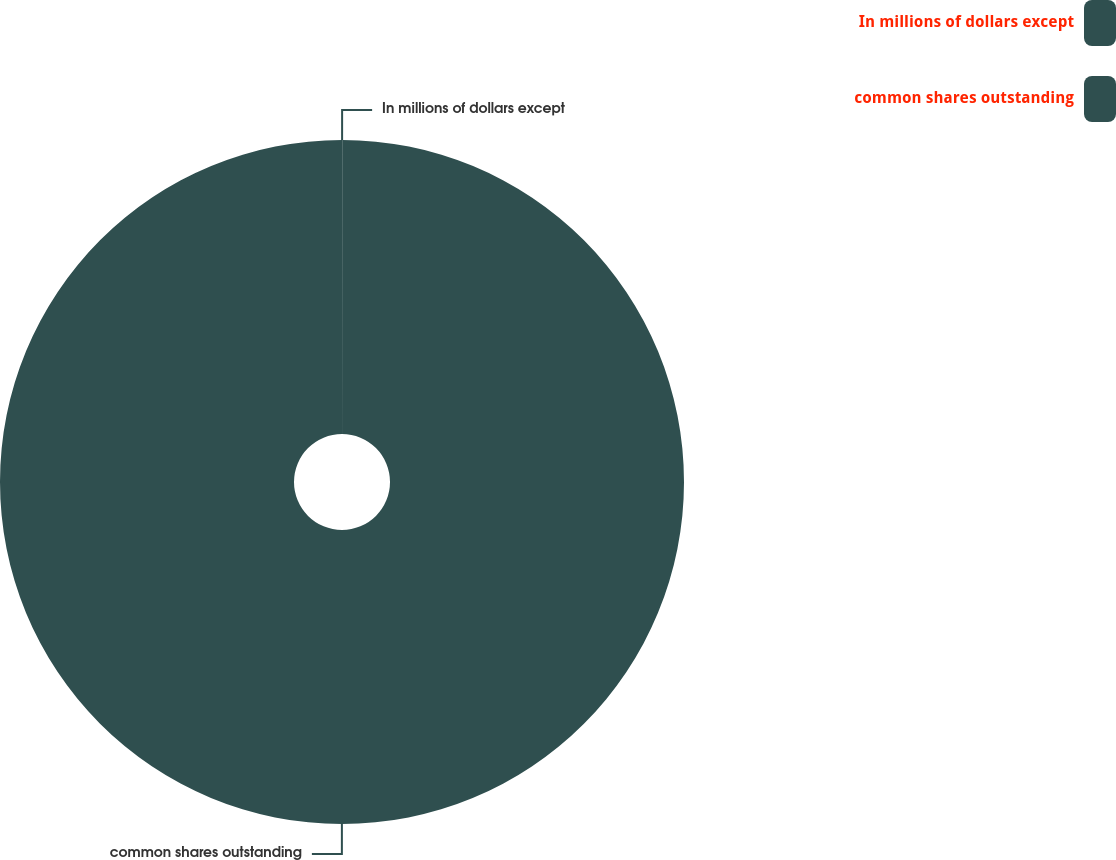Convert chart to OTSL. <chart><loc_0><loc_0><loc_500><loc_500><pie_chart><fcel>In millions of dollars except<fcel>common shares outstanding<nl><fcel>0.01%<fcel>99.99%<nl></chart> 